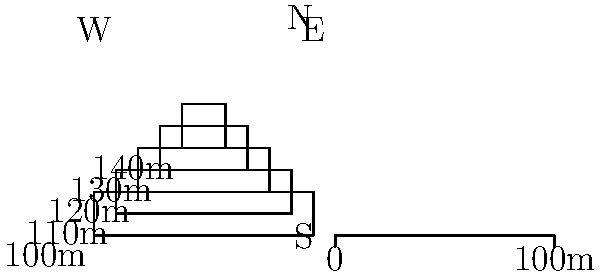A lava flow from a recent volcanic eruption has been mapped using contour lines as shown in the figure above. The contour interval is 10 meters, and the scale shows 100 meters. Estimate the volume of the lava flow assuming it has a uniform thickness of 30 meters. Round your answer to the nearest 10,000 cubic meters. To estimate the volume of the lava flow, we need to:

1. Calculate the area of each contour level.
2. Use the trapezoidal rule to estimate the total volume.

Step 1: Calculate areas of contour levels
- 100m contour: $A_1 = 100m \times 20m = 2000m^2$
- 110m contour: $A_2 = 80m \times 20m = 1600m^2$
- 120m contour: $A_3 = 60m \times 20m = 1200m^2$
- 130m contour: $A_4 = 40m \times 20m = 800m^2$
- 140m contour: $A_5 = 20m \times 20m = 400m^2$

Step 2: Apply the trapezoidal rule
Volume = $\frac{h}{2}(A_1 + A_n + 2(A_2 + A_3 + ... + A_{n-1}))$
where $h$ is the contour interval (10m) and $n$ is the number of contours (5).

$V = \frac{10}{2}(2000 + 400 + 2(1600 + 1200 + 800))$
$V = 5(2400 + 7200) = 5(9600) = 48000m^3$

Step 3: Adjust for uniform thickness
The question states a uniform thickness of 30m, so we need to scale our result:
$V_{total} = 48000 \times \frac{30}{40} = 36000m^3$

Rounding to the nearest 10,000 cubic meters: 40,000 $m^3$
Answer: 40,000 $m^3$ 